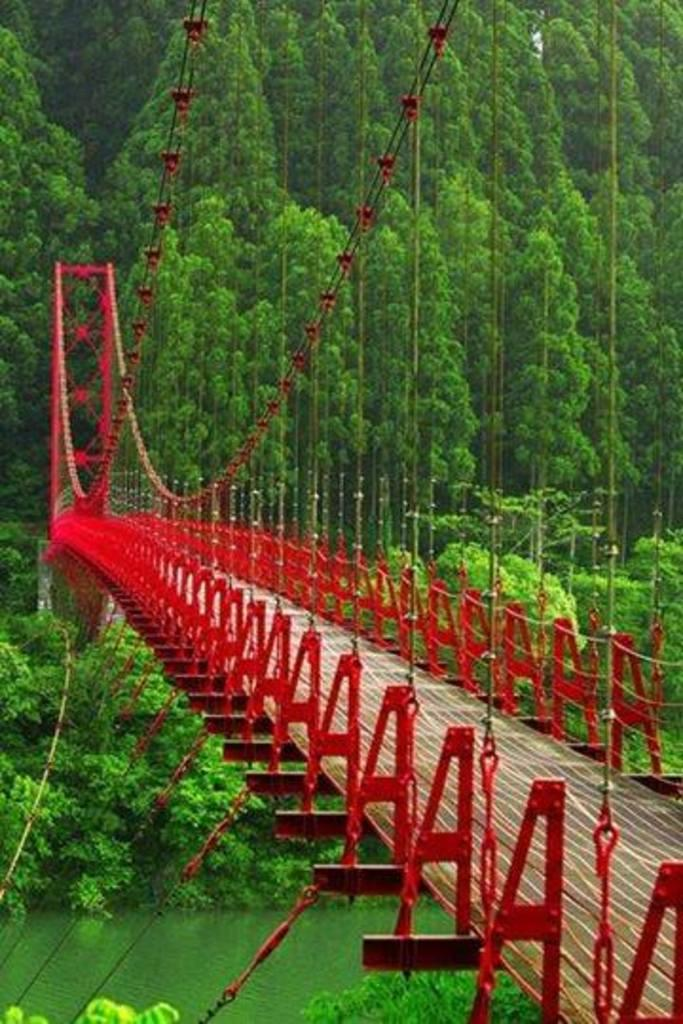What type of structure can be seen in the image? There is a bridge in the image. What type of vegetation is present in the image? There are trees and plants in the image. What natural element is visible in the image? There is water visible in the image. What type of material is present in the image? There are ropes in the image. How many cars are parked on the bridge in the image? There are no cars present in the image; it only features a bridge, trees, plants, water, and ropes. What type of lamp is hanging from the trees in the image? There are no lamps present in the image; it only features a bridge, trees, plants, water, and ropes. 